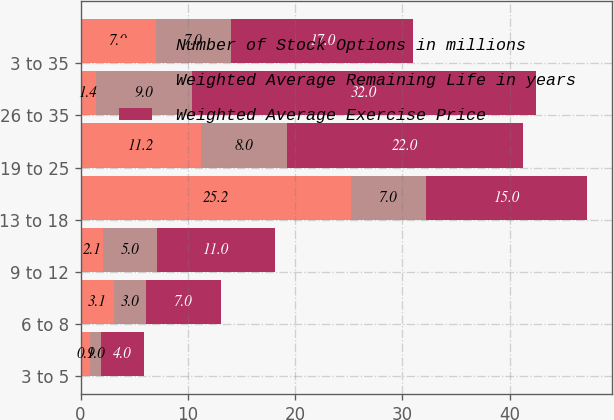Convert chart. <chart><loc_0><loc_0><loc_500><loc_500><stacked_bar_chart><ecel><fcel>3 to 5<fcel>6 to 8<fcel>9 to 12<fcel>13 to 18<fcel>19 to 25<fcel>26 to 35<fcel>3 to 35<nl><fcel>Number of Stock Options in millions<fcel>0.9<fcel>3.1<fcel>2.1<fcel>25.2<fcel>11.2<fcel>1.4<fcel>7<nl><fcel>Weighted Average Remaining Life in years<fcel>1<fcel>3<fcel>5<fcel>7<fcel>8<fcel>9<fcel>7<nl><fcel>Weighted Average Exercise Price<fcel>4<fcel>7<fcel>11<fcel>15<fcel>22<fcel>32<fcel>17<nl></chart> 